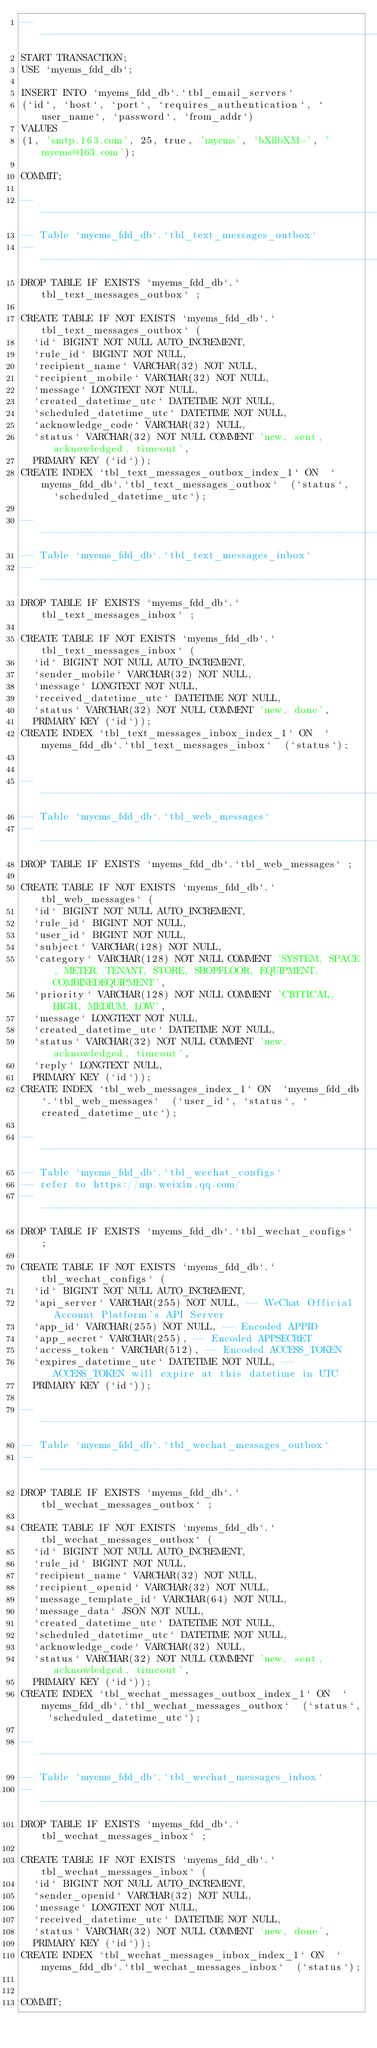<code> <loc_0><loc_0><loc_500><loc_500><_SQL_>-- ----------------------------------------------------------------------------------
START TRANSACTION;
USE `myems_fdd_db`;

INSERT INTO `myems_fdd_db`.`tbl_email_servers`
(`id`, `host`, `port`, `requires_authentication`, `user_name`, `password`, `from_addr`)
VALUES
(1, 'smtp.163.com', 25, true, 'myems', 'bXllbXM=', 'myems@163.com');

COMMIT;

-- ----------------------------------------------------------------------------------
-- Table `myems_fdd_db`.`tbl_text_messages_outbox`
-- ----------------------------------------------------------------------------------
DROP TABLE IF EXISTS `myems_fdd_db`.`tbl_text_messages_outbox` ;

CREATE TABLE IF NOT EXISTS `myems_fdd_db`.`tbl_text_messages_outbox` (
  `id` BIGINT NOT NULL AUTO_INCREMENT,
  `rule_id` BIGINT NOT NULL,
  `recipient_name` VARCHAR(32) NOT NULL,
  `recipient_mobile` VARCHAR(32) NOT NULL,
  `message` LONGTEXT NOT NULL,
  `created_datetime_utc` DATETIME NOT NULL,
  `scheduled_datetime_utc` DATETIME NOT NULL,
  `acknowledge_code` VARCHAR(32) NULL,
  `status` VARCHAR(32) NOT NULL COMMENT 'new, sent, acknowledged, timeout',
  PRIMARY KEY (`id`));
CREATE INDEX `tbl_text_messages_outbox_index_1` ON  `myems_fdd_db`.`tbl_text_messages_outbox`  (`status`,   `scheduled_datetime_utc`);

-- ----------------------------------------------------------------------------------
-- Table `myems_fdd_db`.`tbl_text_messages_inbox`
-- ----------------------------------------------------------------------------------
DROP TABLE IF EXISTS `myems_fdd_db`.`tbl_text_messages_inbox` ;

CREATE TABLE IF NOT EXISTS `myems_fdd_db`.`tbl_text_messages_inbox` (
  `id` BIGINT NOT NULL AUTO_INCREMENT,
  `sender_mobile` VARCHAR(32) NOT NULL,
  `message` LONGTEXT NOT NULL,
  `received_datetime_utc` DATETIME NOT NULL,
  `status` VARCHAR(32) NOT NULL COMMENT 'new, done',
  PRIMARY KEY (`id`));
CREATE INDEX `tbl_text_messages_inbox_index_1` ON  `myems_fdd_db`.`tbl_text_messages_inbox`  (`status`);


-- ----------------------------------------------------------------------------------
-- Table `myems_fdd_db`.`tbl_web_messages`
-- ----------------------------------------------------------------------------------
DROP TABLE IF EXISTS `myems_fdd_db`.`tbl_web_messages` ;

CREATE TABLE IF NOT EXISTS `myems_fdd_db`.`tbl_web_messages` (
  `id` BIGINT NOT NULL AUTO_INCREMENT,
  `rule_id` BIGINT NOT NULL,
  `user_id` BIGINT NOT NULL,
  `subject` VARCHAR(128) NOT NULL,
  `category` VARCHAR(128) NOT NULL COMMENT 'SYSTEM, SPACE, METER, TENANT, STORE, SHOPFLOOR, EQUIPMENT, COMBINEDEQUIPMENT',
  `priority` VARCHAR(128) NOT NULL COMMENT 'CRITICAL, HIGH, MEDIUM, LOW',
  `message` LONGTEXT NOT NULL,
  `created_datetime_utc` DATETIME NOT NULL,
  `status` VARCHAR(32) NOT NULL COMMENT 'new, acknowledged, timeout',
  `reply` LONGTEXT NULL,
  PRIMARY KEY (`id`));
CREATE INDEX `tbl_web_messages_index_1` ON  `myems_fdd_db`.`tbl_web_messages`  (`user_id`, `status`, `created_datetime_utc`);

-- ----------------------------------------------------------------------------------
-- Table `myems_fdd_db`.`tbl_wechat_configs`
-- refer to https://mp.weixin.qq.com/
-- ----------------------------------------------------------------------------------
DROP TABLE IF EXISTS `myems_fdd_db`.`tbl_wechat_configs` ;

CREATE TABLE IF NOT EXISTS `myems_fdd_db`.`tbl_wechat_configs` (
  `id` BIGINT NOT NULL AUTO_INCREMENT,
  `api_server` VARCHAR(255) NOT NULL, -- WeChat Official Account Platform's API Server
  `app_id` VARCHAR(255) NOT NULL, -- Encoded APPID
  `app_secret` VARCHAR(255), -- Encoded APPSECRET
  `access_token` VARCHAR(512), -- Encoded ACCESS_TOKEN
  `expires_datetime_utc` DATETIME NOT NULL, -- ACCESS_TOKEN will expire at this datetime in UTC
  PRIMARY KEY (`id`));

-- ----------------------------------------------------------------------------------
-- Table `myems_fdd_db`.`tbl_wechat_messages_outbox`
-- ----------------------------------------------------------------------------------
DROP TABLE IF EXISTS `myems_fdd_db`.`tbl_wechat_messages_outbox` ;

CREATE TABLE IF NOT EXISTS `myems_fdd_db`.`tbl_wechat_messages_outbox` (
  `id` BIGINT NOT NULL AUTO_INCREMENT,
  `rule_id` BIGINT NOT NULL,
  `recipient_name` VARCHAR(32) NOT NULL,
  `recipient_openid` VARCHAR(32) NOT NULL,
  `message_template_id` VARCHAR(64) NOT NULL,
  `message_data` JSON NOT NULL,
  `created_datetime_utc` DATETIME NOT NULL,
  `scheduled_datetime_utc` DATETIME NOT NULL,
  `acknowledge_code` VARCHAR(32) NULL,
  `status` VARCHAR(32) NOT NULL COMMENT 'new, sent, acknowledged, timeout',
  PRIMARY KEY (`id`));
CREATE INDEX `tbl_wechat_messages_outbox_index_1` ON  `myems_fdd_db`.`tbl_wechat_messages_outbox`  (`status`, `scheduled_datetime_utc`);

-- ----------------------------------------------------------------------------------
-- Table `myems_fdd_db`.`tbl_wechat_messages_inbox`
-- ----------------------------------------------------------------------------------
DROP TABLE IF EXISTS `myems_fdd_db`.`tbl_wechat_messages_inbox` ;

CREATE TABLE IF NOT EXISTS `myems_fdd_db`.`tbl_wechat_messages_inbox` (
  `id` BIGINT NOT NULL AUTO_INCREMENT,
  `sender_openid` VARCHAR(32) NOT NULL,
  `message` LONGTEXT NOT NULL,
  `received_datetime_utc` DATETIME NOT NULL,
  `status` VARCHAR(32) NOT NULL COMMENT 'new, done',
  PRIMARY KEY (`id`));
CREATE INDEX `tbl_wechat_messages_inbox_index_1` ON  `myems_fdd_db`.`tbl_wechat_messages_inbox`  (`status`);


COMMIT;
</code> 